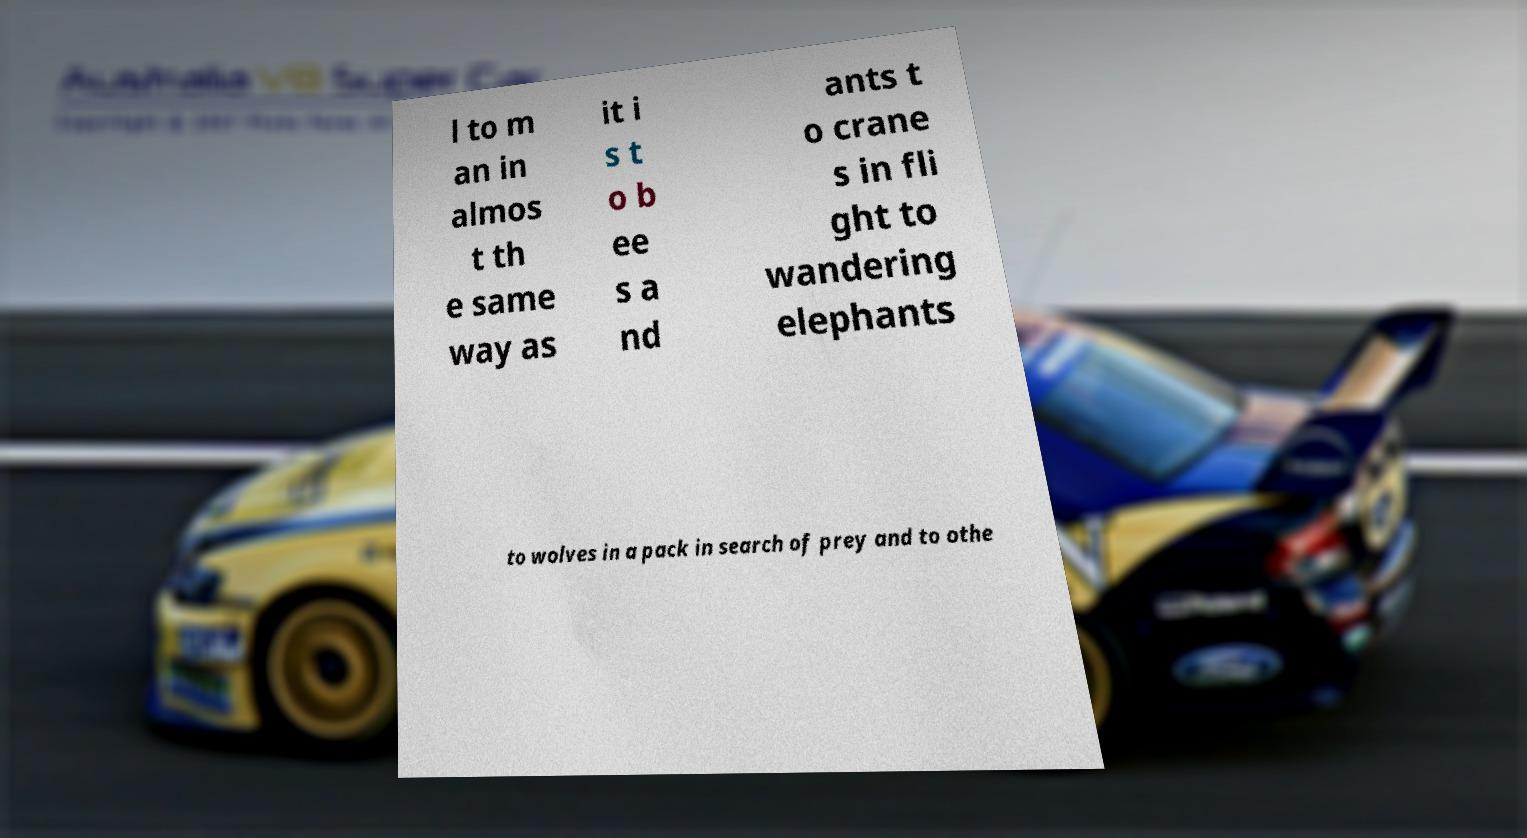Can you read and provide the text displayed in the image?This photo seems to have some interesting text. Can you extract and type it out for me? l to m an in almos t th e same way as it i s t o b ee s a nd ants t o crane s in fli ght to wandering elephants to wolves in a pack in search of prey and to othe 